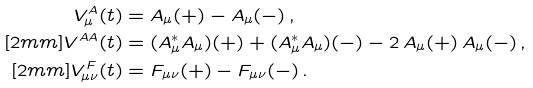<formula> <loc_0><loc_0><loc_500><loc_500>V _ { \mu } ^ { A } ( t ) & = A _ { \mu } ( + ) - A _ { \mu } ( - ) \, , \\ [ 2 m m ] V ^ { A A } ( t ) & = ( A _ { \mu } ^ { * } A _ { \mu } ) ( + ) + ( A _ { \mu } ^ { * } A _ { \mu } ) ( - ) - 2 \, A _ { \mu } ( + ) \, A _ { \mu } ( - ) \, , \\ [ 2 m m ] V _ { \mu \nu } ^ { F } ( t ) & = F _ { \mu \nu } ( + ) - F _ { \mu \nu } ( - ) \, .</formula> 